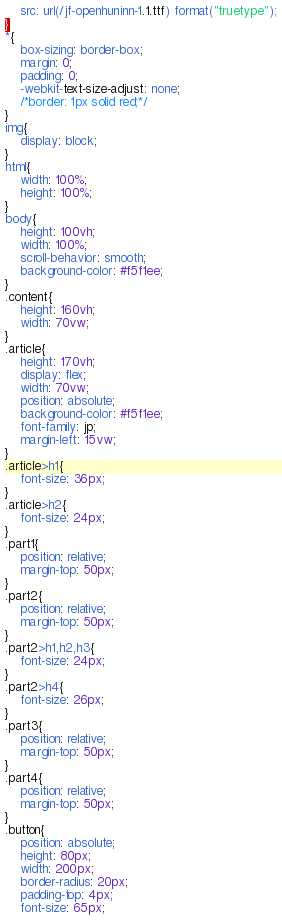<code> <loc_0><loc_0><loc_500><loc_500><_CSS_>    src: url(/jf-openhuninn-1.1.ttf) format("truetype");
}
*{
    box-sizing: border-box;
    margin: 0;
    padding: 0;
    -webkit-text-size-adjust: none;
    /*border: 1px solid red;*/
}
img{
    display: block;
}
html{
    width: 100%;
    height: 100%;
}
body{
    height: 100vh;
    width: 100%;
    scroll-behavior: smooth;
    background-color: #f5f1ee;
}
.content{
    height: 160vh;
    width: 70vw;
}
.article{
    height: 170vh;
    display: flex;
    width: 70vw;
    position: absolute;
    background-color: #f5f1ee;
    font-family: jp;
    margin-left: 15vw;
}
.article>h1{
    font-size: 36px;
}
.article>h2{
    font-size: 24px;    
}
.part1{
    position: relative;
    margin-top: 50px;
}
.part2{
    position: relative;
    margin-top: 50px;
}
.part2>h1,h2,h3{
    font-size: 24px;
}
.part2>h4{
    font-size: 26px;
}
.part3{
    position: relative;
    margin-top: 50px;
}
.part4{
    position: relative;
    margin-top: 50px;
}
.button{
    position: absolute;
    height: 80px;
    width: 200px;
    border-radius: 20px;
    padding-top: 4px;
    font-size: 65px;</code> 